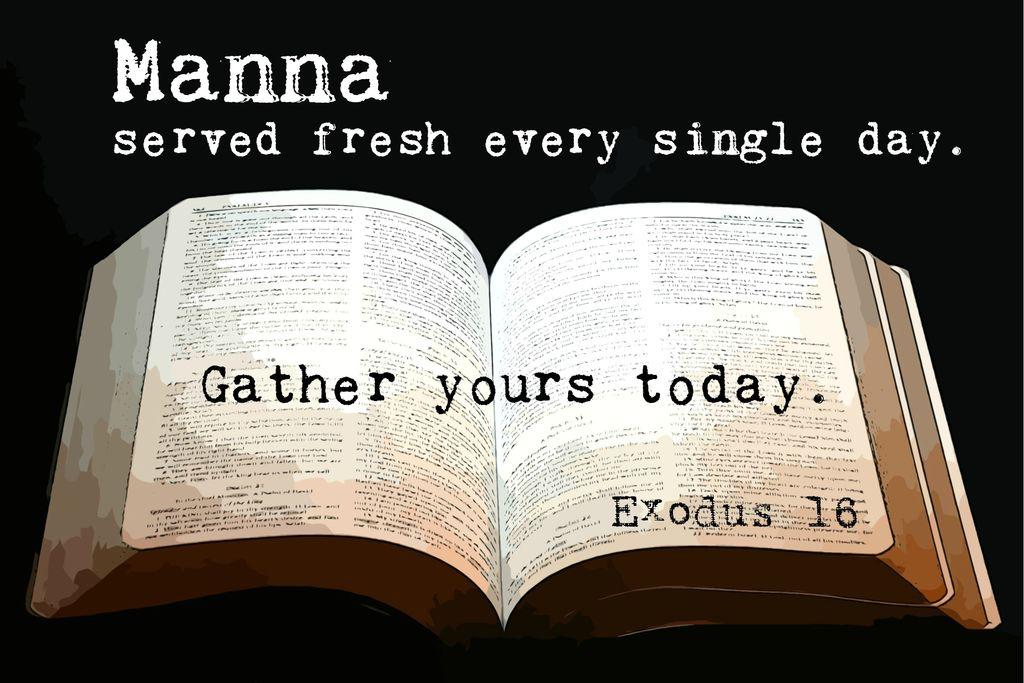<image>
Render a clear and concise summary of the photo. A bible is opened with "Gather yours today, Exodus 16." 